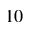<formula> <loc_0><loc_0><loc_500><loc_500>1 0</formula> 